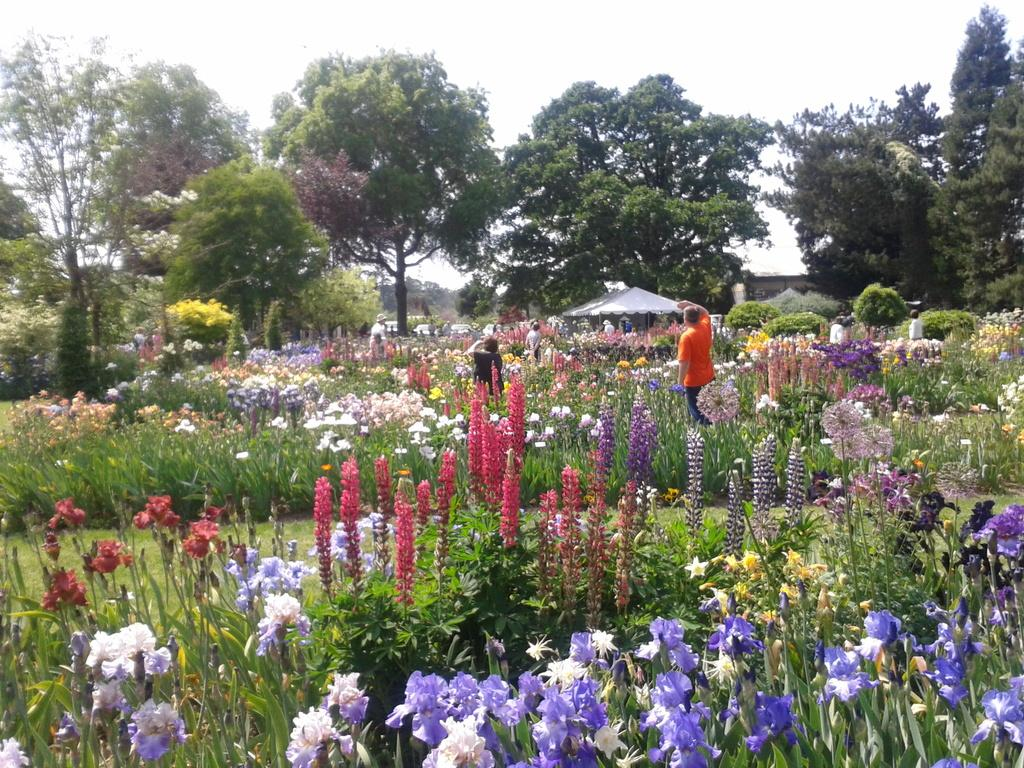What type of vegetation can be seen in the image? There are plants, trees, and grass in the image. Are there any specific types of plants in the image? Yes, there are flower plants in the image. Who or what else is present in the image? There are people and a tent in the image. What can be seen in the sky in the image? The sky is visible in the image. What type of prose is being recited by the trees in the image? There are no trees reciting prose in the image; the trees are stationary plants. How many oranges are hanging from the branches of the trees in the image? There are no oranges present in the image; the trees are not fruit-bearing trees. 